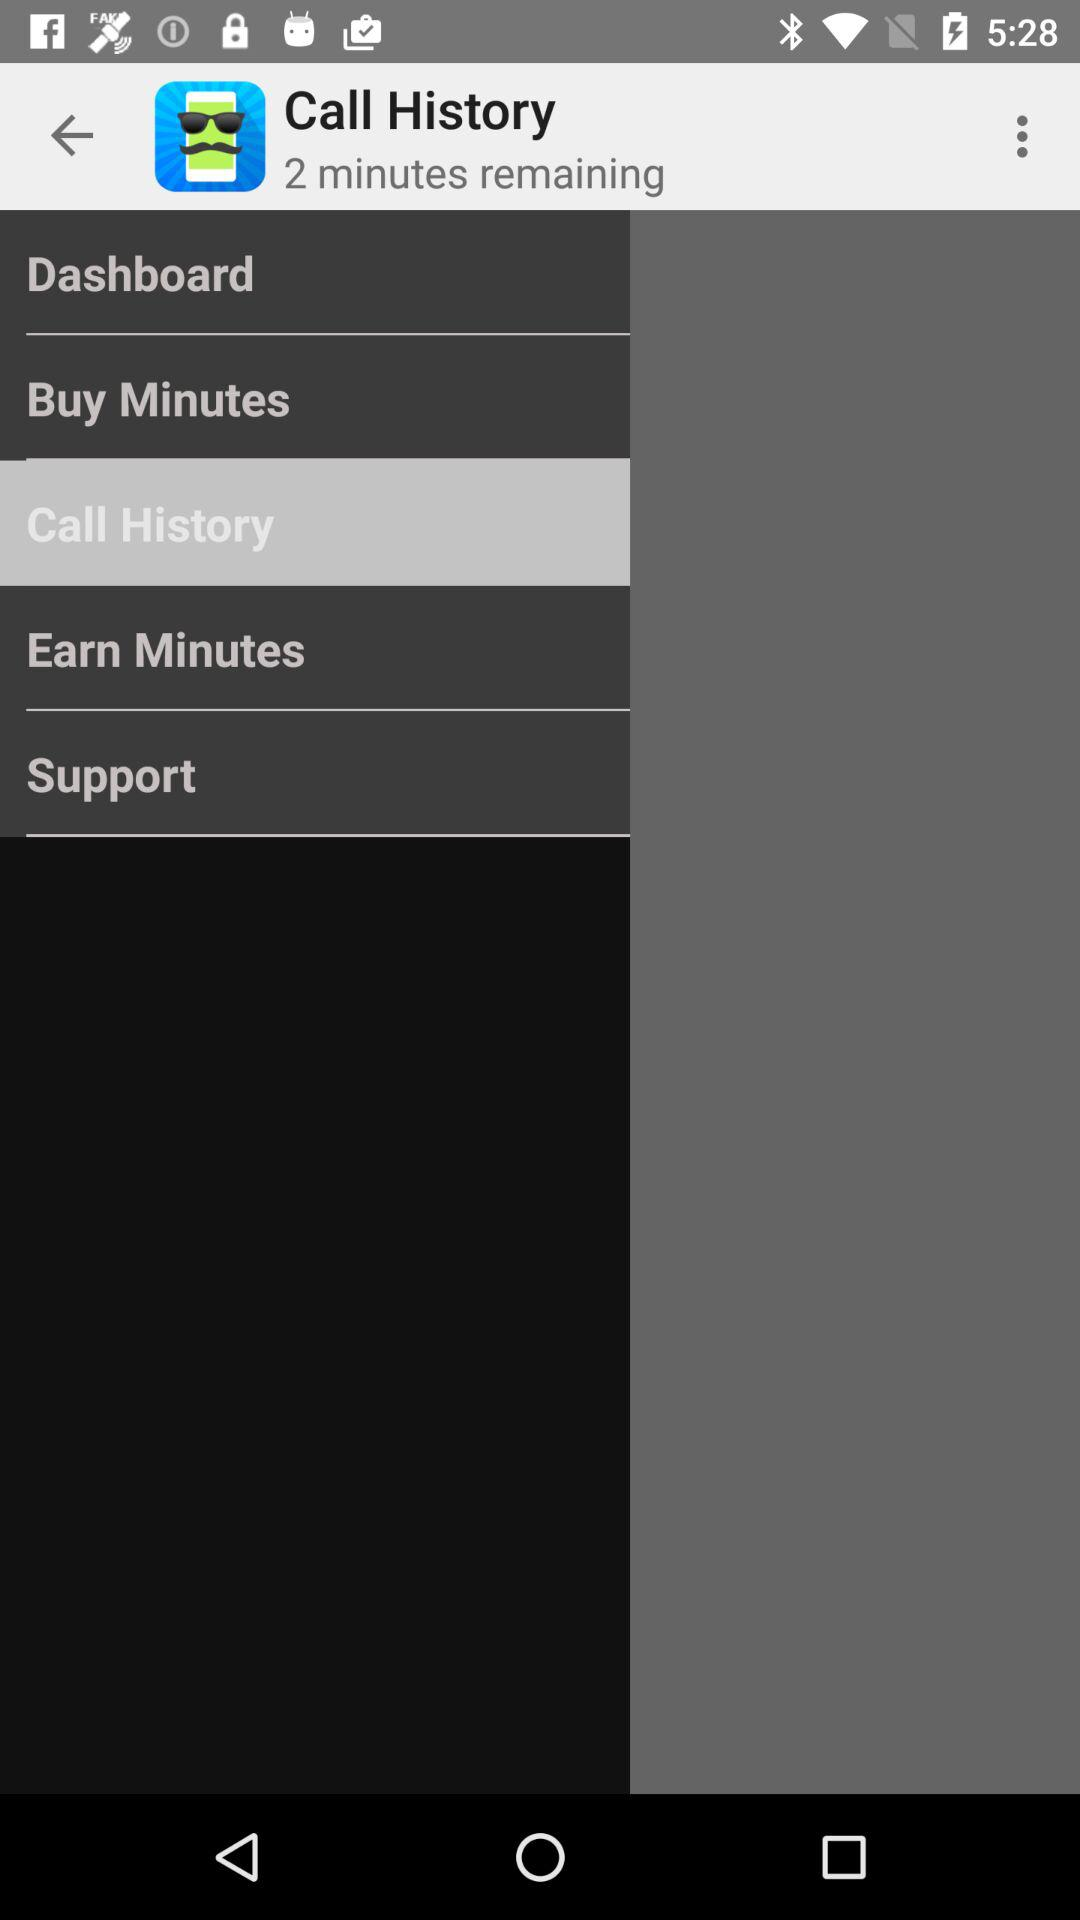How much time is remaining? The remaining time is 2 minutes. 